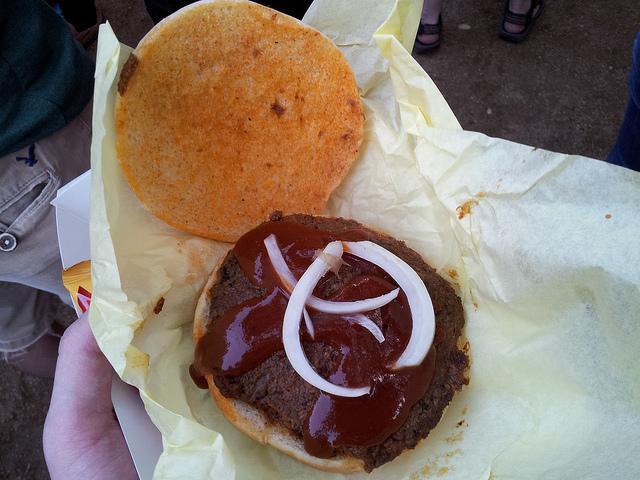How many people are visible?
Give a very brief answer. 3. 